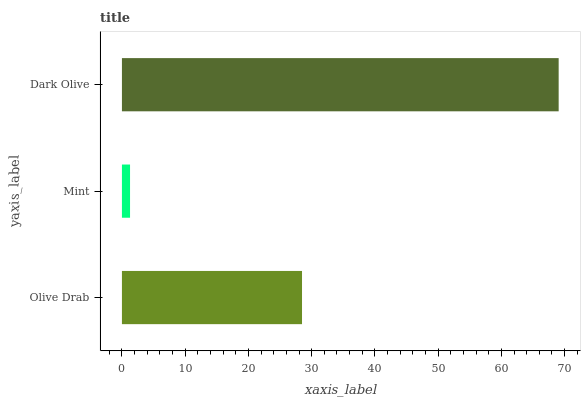Is Mint the minimum?
Answer yes or no. Yes. Is Dark Olive the maximum?
Answer yes or no. Yes. Is Dark Olive the minimum?
Answer yes or no. No. Is Mint the maximum?
Answer yes or no. No. Is Dark Olive greater than Mint?
Answer yes or no. Yes. Is Mint less than Dark Olive?
Answer yes or no. Yes. Is Mint greater than Dark Olive?
Answer yes or no. No. Is Dark Olive less than Mint?
Answer yes or no. No. Is Olive Drab the high median?
Answer yes or no. Yes. Is Olive Drab the low median?
Answer yes or no. Yes. Is Mint the high median?
Answer yes or no. No. Is Mint the low median?
Answer yes or no. No. 